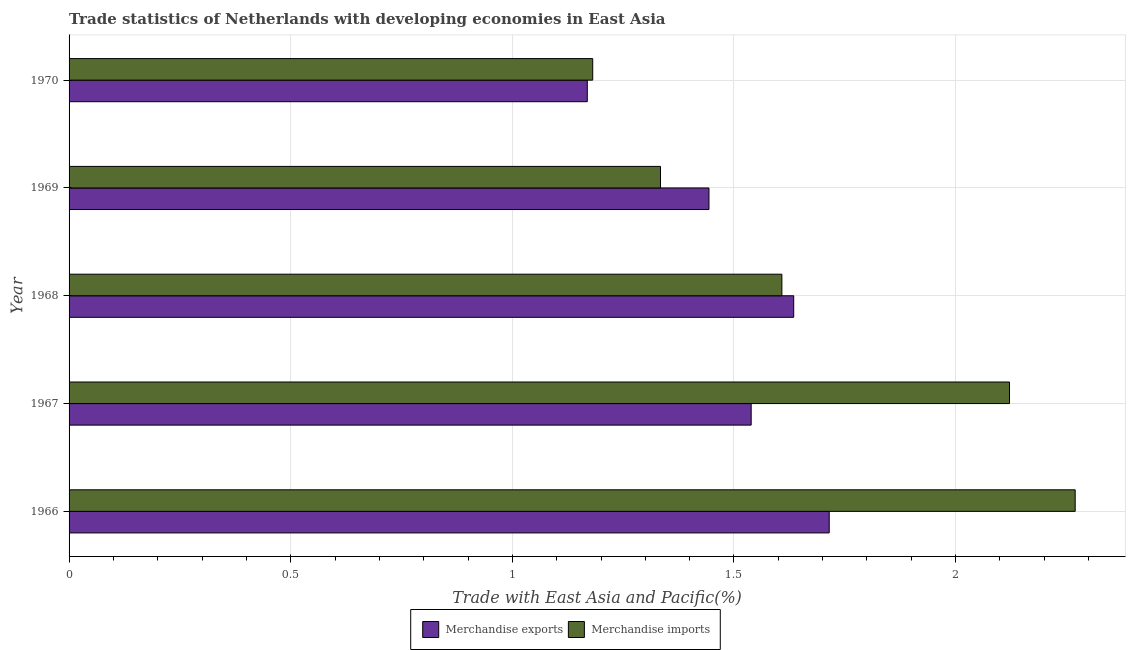How many groups of bars are there?
Keep it short and to the point. 5. How many bars are there on the 5th tick from the top?
Offer a very short reply. 2. How many bars are there on the 3rd tick from the bottom?
Give a very brief answer. 2. What is the label of the 2nd group of bars from the top?
Provide a short and direct response. 1969. What is the merchandise imports in 1966?
Give a very brief answer. 2.27. Across all years, what is the maximum merchandise exports?
Your answer should be very brief. 1.71. Across all years, what is the minimum merchandise exports?
Ensure brevity in your answer.  1.17. In which year was the merchandise exports maximum?
Make the answer very short. 1966. What is the total merchandise exports in the graph?
Offer a terse response. 7.5. What is the difference between the merchandise exports in 1967 and that in 1969?
Ensure brevity in your answer.  0.1. What is the difference between the merchandise imports in 1966 and the merchandise exports in 1967?
Provide a succinct answer. 0.73. What is the average merchandise exports per year?
Your answer should be compact. 1.5. In the year 1970, what is the difference between the merchandise imports and merchandise exports?
Your answer should be very brief. 0.01. What is the ratio of the merchandise imports in 1966 to that in 1967?
Your answer should be compact. 1.07. Is the difference between the merchandise exports in 1969 and 1970 greater than the difference between the merchandise imports in 1969 and 1970?
Offer a very short reply. Yes. What is the difference between the highest and the second highest merchandise imports?
Your response must be concise. 0.15. What is the difference between the highest and the lowest merchandise imports?
Your response must be concise. 1.09. Is the sum of the merchandise exports in 1967 and 1968 greater than the maximum merchandise imports across all years?
Your response must be concise. Yes. What does the 2nd bar from the bottom in 1968 represents?
Ensure brevity in your answer.  Merchandise imports. Are all the bars in the graph horizontal?
Offer a very short reply. Yes. How many years are there in the graph?
Offer a terse response. 5. Does the graph contain any zero values?
Offer a terse response. No. Does the graph contain grids?
Your answer should be very brief. Yes. How are the legend labels stacked?
Make the answer very short. Horizontal. What is the title of the graph?
Make the answer very short. Trade statistics of Netherlands with developing economies in East Asia. What is the label or title of the X-axis?
Ensure brevity in your answer.  Trade with East Asia and Pacific(%). What is the Trade with East Asia and Pacific(%) in Merchandise exports in 1966?
Make the answer very short. 1.71. What is the Trade with East Asia and Pacific(%) in Merchandise imports in 1966?
Provide a succinct answer. 2.27. What is the Trade with East Asia and Pacific(%) of Merchandise exports in 1967?
Provide a succinct answer. 1.54. What is the Trade with East Asia and Pacific(%) of Merchandise imports in 1967?
Make the answer very short. 2.12. What is the Trade with East Asia and Pacific(%) in Merchandise exports in 1968?
Your answer should be very brief. 1.63. What is the Trade with East Asia and Pacific(%) of Merchandise imports in 1968?
Provide a short and direct response. 1.61. What is the Trade with East Asia and Pacific(%) in Merchandise exports in 1969?
Provide a short and direct response. 1.44. What is the Trade with East Asia and Pacific(%) in Merchandise imports in 1969?
Provide a short and direct response. 1.33. What is the Trade with East Asia and Pacific(%) of Merchandise exports in 1970?
Offer a terse response. 1.17. What is the Trade with East Asia and Pacific(%) of Merchandise imports in 1970?
Your answer should be very brief. 1.18. Across all years, what is the maximum Trade with East Asia and Pacific(%) of Merchandise exports?
Give a very brief answer. 1.71. Across all years, what is the maximum Trade with East Asia and Pacific(%) of Merchandise imports?
Your response must be concise. 2.27. Across all years, what is the minimum Trade with East Asia and Pacific(%) in Merchandise exports?
Provide a succinct answer. 1.17. Across all years, what is the minimum Trade with East Asia and Pacific(%) in Merchandise imports?
Offer a terse response. 1.18. What is the total Trade with East Asia and Pacific(%) in Merchandise exports in the graph?
Make the answer very short. 7.5. What is the total Trade with East Asia and Pacific(%) of Merchandise imports in the graph?
Provide a succinct answer. 8.51. What is the difference between the Trade with East Asia and Pacific(%) of Merchandise exports in 1966 and that in 1967?
Make the answer very short. 0.18. What is the difference between the Trade with East Asia and Pacific(%) in Merchandise imports in 1966 and that in 1967?
Your response must be concise. 0.15. What is the difference between the Trade with East Asia and Pacific(%) of Merchandise exports in 1966 and that in 1968?
Keep it short and to the point. 0.08. What is the difference between the Trade with East Asia and Pacific(%) of Merchandise imports in 1966 and that in 1968?
Your answer should be very brief. 0.66. What is the difference between the Trade with East Asia and Pacific(%) in Merchandise exports in 1966 and that in 1969?
Offer a terse response. 0.27. What is the difference between the Trade with East Asia and Pacific(%) of Merchandise imports in 1966 and that in 1969?
Keep it short and to the point. 0.94. What is the difference between the Trade with East Asia and Pacific(%) of Merchandise exports in 1966 and that in 1970?
Provide a short and direct response. 0.55. What is the difference between the Trade with East Asia and Pacific(%) of Merchandise imports in 1966 and that in 1970?
Provide a succinct answer. 1.09. What is the difference between the Trade with East Asia and Pacific(%) of Merchandise exports in 1967 and that in 1968?
Provide a short and direct response. -0.1. What is the difference between the Trade with East Asia and Pacific(%) in Merchandise imports in 1967 and that in 1968?
Your response must be concise. 0.51. What is the difference between the Trade with East Asia and Pacific(%) in Merchandise exports in 1967 and that in 1969?
Ensure brevity in your answer.  0.1. What is the difference between the Trade with East Asia and Pacific(%) in Merchandise imports in 1967 and that in 1969?
Your response must be concise. 0.79. What is the difference between the Trade with East Asia and Pacific(%) in Merchandise exports in 1967 and that in 1970?
Ensure brevity in your answer.  0.37. What is the difference between the Trade with East Asia and Pacific(%) in Merchandise imports in 1967 and that in 1970?
Keep it short and to the point. 0.94. What is the difference between the Trade with East Asia and Pacific(%) in Merchandise exports in 1968 and that in 1969?
Provide a succinct answer. 0.19. What is the difference between the Trade with East Asia and Pacific(%) in Merchandise imports in 1968 and that in 1969?
Your answer should be very brief. 0.27. What is the difference between the Trade with East Asia and Pacific(%) in Merchandise exports in 1968 and that in 1970?
Provide a succinct answer. 0.47. What is the difference between the Trade with East Asia and Pacific(%) in Merchandise imports in 1968 and that in 1970?
Your response must be concise. 0.43. What is the difference between the Trade with East Asia and Pacific(%) of Merchandise exports in 1969 and that in 1970?
Ensure brevity in your answer.  0.27. What is the difference between the Trade with East Asia and Pacific(%) of Merchandise imports in 1969 and that in 1970?
Offer a very short reply. 0.15. What is the difference between the Trade with East Asia and Pacific(%) of Merchandise exports in 1966 and the Trade with East Asia and Pacific(%) of Merchandise imports in 1967?
Your answer should be compact. -0.41. What is the difference between the Trade with East Asia and Pacific(%) in Merchandise exports in 1966 and the Trade with East Asia and Pacific(%) in Merchandise imports in 1968?
Keep it short and to the point. 0.11. What is the difference between the Trade with East Asia and Pacific(%) of Merchandise exports in 1966 and the Trade with East Asia and Pacific(%) of Merchandise imports in 1969?
Ensure brevity in your answer.  0.38. What is the difference between the Trade with East Asia and Pacific(%) in Merchandise exports in 1966 and the Trade with East Asia and Pacific(%) in Merchandise imports in 1970?
Provide a short and direct response. 0.53. What is the difference between the Trade with East Asia and Pacific(%) of Merchandise exports in 1967 and the Trade with East Asia and Pacific(%) of Merchandise imports in 1968?
Your response must be concise. -0.07. What is the difference between the Trade with East Asia and Pacific(%) of Merchandise exports in 1967 and the Trade with East Asia and Pacific(%) of Merchandise imports in 1969?
Keep it short and to the point. 0.2. What is the difference between the Trade with East Asia and Pacific(%) of Merchandise exports in 1967 and the Trade with East Asia and Pacific(%) of Merchandise imports in 1970?
Provide a succinct answer. 0.36. What is the difference between the Trade with East Asia and Pacific(%) in Merchandise exports in 1968 and the Trade with East Asia and Pacific(%) in Merchandise imports in 1969?
Offer a very short reply. 0.3. What is the difference between the Trade with East Asia and Pacific(%) of Merchandise exports in 1968 and the Trade with East Asia and Pacific(%) of Merchandise imports in 1970?
Your answer should be compact. 0.45. What is the difference between the Trade with East Asia and Pacific(%) of Merchandise exports in 1969 and the Trade with East Asia and Pacific(%) of Merchandise imports in 1970?
Ensure brevity in your answer.  0.26. What is the average Trade with East Asia and Pacific(%) of Merchandise exports per year?
Your response must be concise. 1.5. What is the average Trade with East Asia and Pacific(%) in Merchandise imports per year?
Provide a succinct answer. 1.7. In the year 1966, what is the difference between the Trade with East Asia and Pacific(%) of Merchandise exports and Trade with East Asia and Pacific(%) of Merchandise imports?
Offer a very short reply. -0.55. In the year 1967, what is the difference between the Trade with East Asia and Pacific(%) of Merchandise exports and Trade with East Asia and Pacific(%) of Merchandise imports?
Your response must be concise. -0.58. In the year 1968, what is the difference between the Trade with East Asia and Pacific(%) of Merchandise exports and Trade with East Asia and Pacific(%) of Merchandise imports?
Ensure brevity in your answer.  0.03. In the year 1969, what is the difference between the Trade with East Asia and Pacific(%) in Merchandise exports and Trade with East Asia and Pacific(%) in Merchandise imports?
Your response must be concise. 0.11. In the year 1970, what is the difference between the Trade with East Asia and Pacific(%) in Merchandise exports and Trade with East Asia and Pacific(%) in Merchandise imports?
Offer a very short reply. -0.01. What is the ratio of the Trade with East Asia and Pacific(%) in Merchandise exports in 1966 to that in 1967?
Your answer should be very brief. 1.11. What is the ratio of the Trade with East Asia and Pacific(%) in Merchandise imports in 1966 to that in 1967?
Provide a short and direct response. 1.07. What is the ratio of the Trade with East Asia and Pacific(%) of Merchandise exports in 1966 to that in 1968?
Your answer should be very brief. 1.05. What is the ratio of the Trade with East Asia and Pacific(%) in Merchandise imports in 1966 to that in 1968?
Offer a terse response. 1.41. What is the ratio of the Trade with East Asia and Pacific(%) in Merchandise exports in 1966 to that in 1969?
Provide a succinct answer. 1.19. What is the ratio of the Trade with East Asia and Pacific(%) in Merchandise imports in 1966 to that in 1969?
Give a very brief answer. 1.7. What is the ratio of the Trade with East Asia and Pacific(%) of Merchandise exports in 1966 to that in 1970?
Keep it short and to the point. 1.47. What is the ratio of the Trade with East Asia and Pacific(%) of Merchandise imports in 1966 to that in 1970?
Provide a short and direct response. 1.92. What is the ratio of the Trade with East Asia and Pacific(%) in Merchandise exports in 1967 to that in 1968?
Ensure brevity in your answer.  0.94. What is the ratio of the Trade with East Asia and Pacific(%) of Merchandise imports in 1967 to that in 1968?
Your answer should be very brief. 1.32. What is the ratio of the Trade with East Asia and Pacific(%) in Merchandise exports in 1967 to that in 1969?
Keep it short and to the point. 1.07. What is the ratio of the Trade with East Asia and Pacific(%) in Merchandise imports in 1967 to that in 1969?
Ensure brevity in your answer.  1.59. What is the ratio of the Trade with East Asia and Pacific(%) in Merchandise exports in 1967 to that in 1970?
Provide a short and direct response. 1.32. What is the ratio of the Trade with East Asia and Pacific(%) in Merchandise imports in 1967 to that in 1970?
Provide a succinct answer. 1.8. What is the ratio of the Trade with East Asia and Pacific(%) in Merchandise exports in 1968 to that in 1969?
Provide a short and direct response. 1.13. What is the ratio of the Trade with East Asia and Pacific(%) in Merchandise imports in 1968 to that in 1969?
Your answer should be compact. 1.21. What is the ratio of the Trade with East Asia and Pacific(%) in Merchandise exports in 1968 to that in 1970?
Make the answer very short. 1.4. What is the ratio of the Trade with East Asia and Pacific(%) in Merchandise imports in 1968 to that in 1970?
Keep it short and to the point. 1.36. What is the ratio of the Trade with East Asia and Pacific(%) of Merchandise exports in 1969 to that in 1970?
Ensure brevity in your answer.  1.23. What is the ratio of the Trade with East Asia and Pacific(%) of Merchandise imports in 1969 to that in 1970?
Offer a very short reply. 1.13. What is the difference between the highest and the second highest Trade with East Asia and Pacific(%) in Merchandise exports?
Your answer should be compact. 0.08. What is the difference between the highest and the second highest Trade with East Asia and Pacific(%) in Merchandise imports?
Ensure brevity in your answer.  0.15. What is the difference between the highest and the lowest Trade with East Asia and Pacific(%) in Merchandise exports?
Make the answer very short. 0.55. What is the difference between the highest and the lowest Trade with East Asia and Pacific(%) of Merchandise imports?
Make the answer very short. 1.09. 